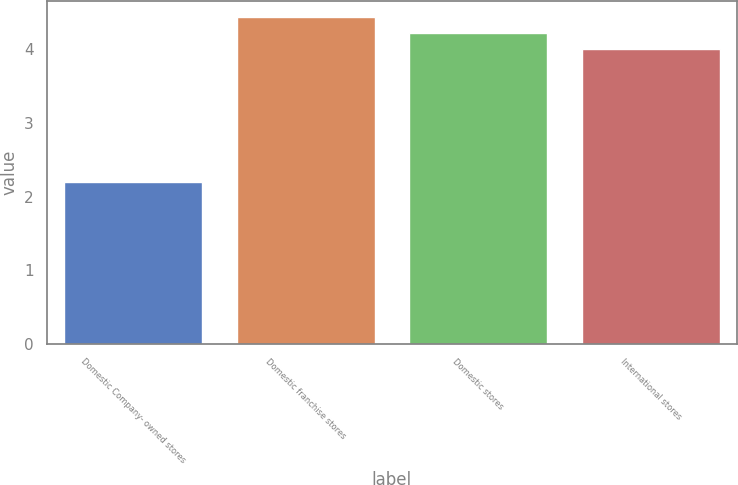Convert chart. <chart><loc_0><loc_0><loc_500><loc_500><bar_chart><fcel>Domestic Company- owned stores<fcel>Domestic franchise stores<fcel>Domestic stores<fcel>International stores<nl><fcel>2.2<fcel>4.44<fcel>4.22<fcel>4<nl></chart> 